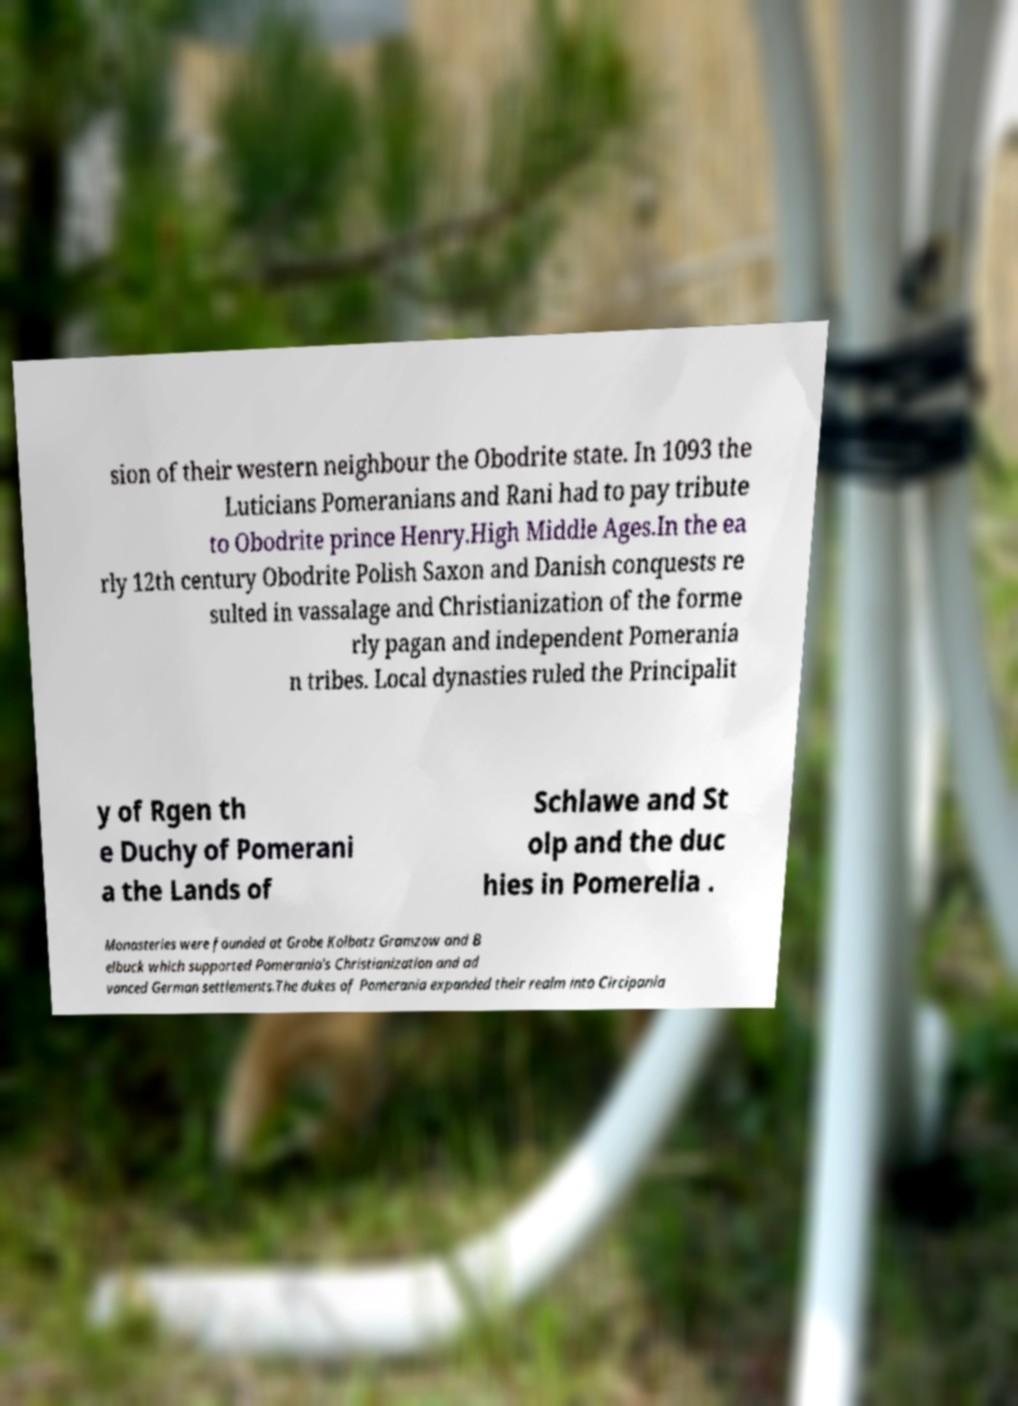There's text embedded in this image that I need extracted. Can you transcribe it verbatim? sion of their western neighbour the Obodrite state. In 1093 the Luticians Pomeranians and Rani had to pay tribute to Obodrite prince Henry.High Middle Ages.In the ea rly 12th century Obodrite Polish Saxon and Danish conquests re sulted in vassalage and Christianization of the forme rly pagan and independent Pomerania n tribes. Local dynasties ruled the Principalit y of Rgen th e Duchy of Pomerani a the Lands of Schlawe and St olp and the duc hies in Pomerelia . Monasteries were founded at Grobe Kolbatz Gramzow and B elbuck which supported Pomerania's Christianization and ad vanced German settlements.The dukes of Pomerania expanded their realm into Circipania 